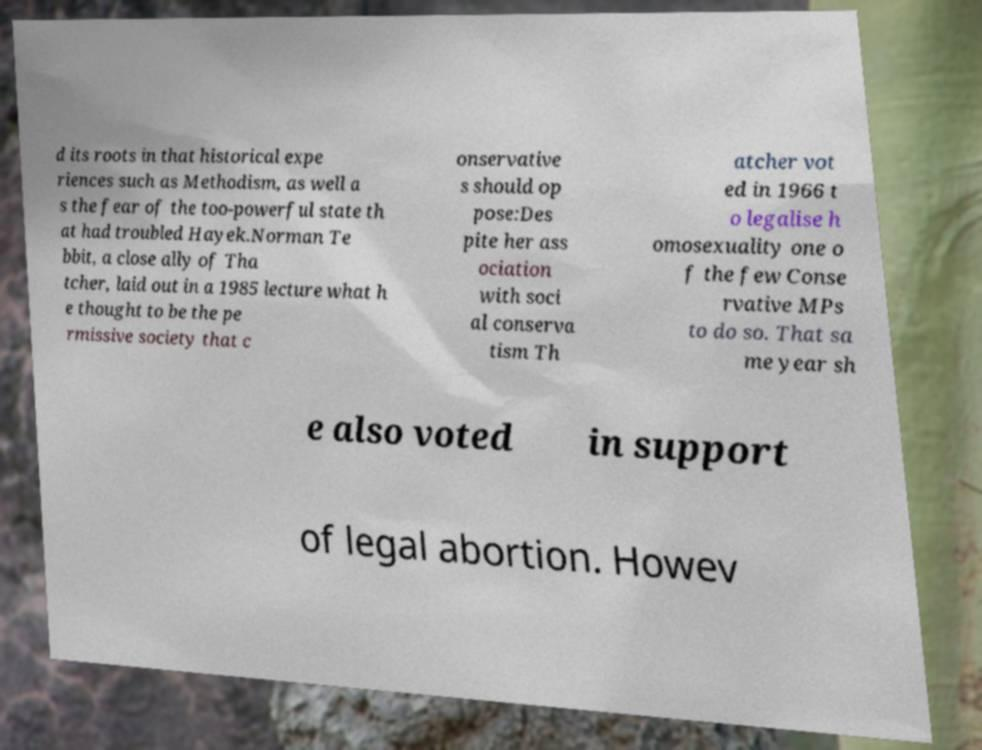Please identify and transcribe the text found in this image. d its roots in that historical expe riences such as Methodism, as well a s the fear of the too-powerful state th at had troubled Hayek.Norman Te bbit, a close ally of Tha tcher, laid out in a 1985 lecture what h e thought to be the pe rmissive society that c onservative s should op pose:Des pite her ass ociation with soci al conserva tism Th atcher vot ed in 1966 t o legalise h omosexuality one o f the few Conse rvative MPs to do so. That sa me year sh e also voted in support of legal abortion. Howev 